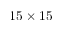<formula> <loc_0><loc_0><loc_500><loc_500>1 5 \times 1 5</formula> 